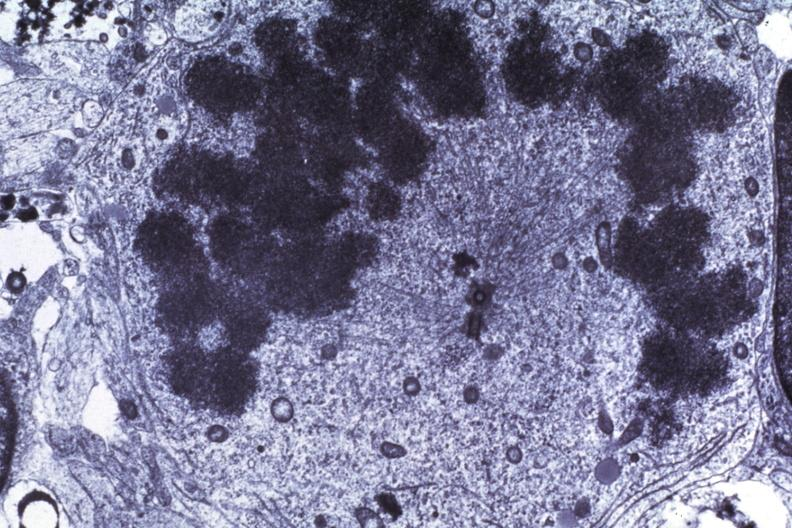s postpartum present?
Answer the question using a single word or phrase. No 